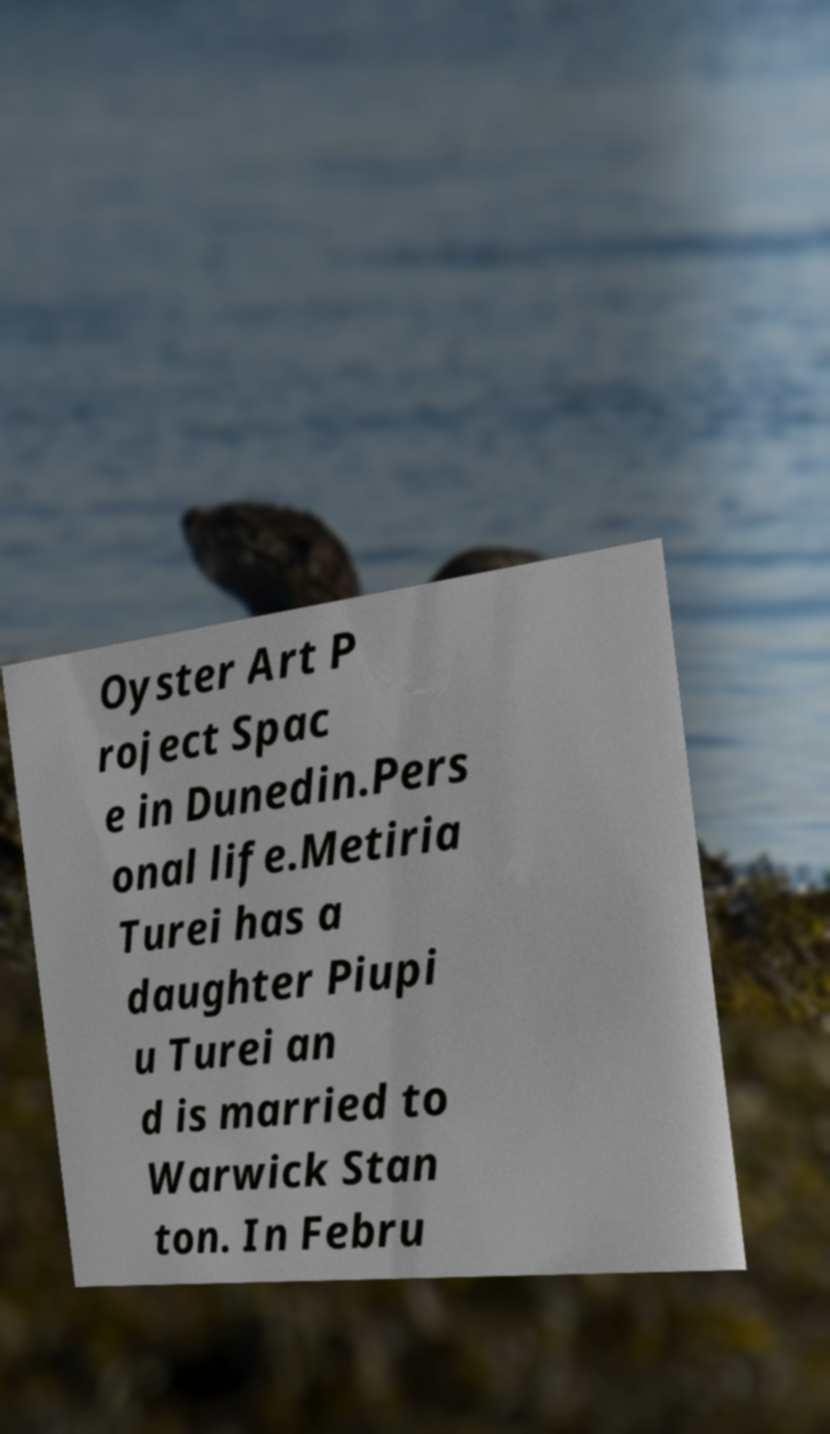What messages or text are displayed in this image? I need them in a readable, typed format. Oyster Art P roject Spac e in Dunedin.Pers onal life.Metiria Turei has a daughter Piupi u Turei an d is married to Warwick Stan ton. In Febru 